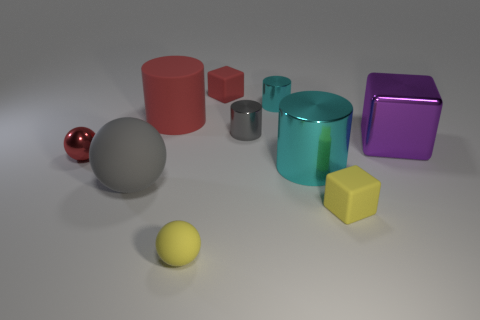What size is the gray matte ball?
Provide a short and direct response. Large. What number of spheres are either gray rubber things or large red objects?
Your answer should be very brief. 1. What size is the red sphere that is made of the same material as the large cyan cylinder?
Your answer should be compact. Small. What number of small shiny things are the same color as the large sphere?
Give a very brief answer. 1. Are there any matte cubes on the left side of the tiny cyan object?
Keep it short and to the point. Yes. There is a gray rubber thing; is its shape the same as the cyan object that is in front of the rubber cylinder?
Provide a succinct answer. No. What number of things are balls in front of the big gray sphere or large purple metal balls?
Give a very brief answer. 1. Are there any other things that are the same material as the big cyan thing?
Ensure brevity in your answer.  Yes. What number of tiny things are both behind the large gray matte ball and in front of the big red rubber object?
Offer a very short reply. 2. How many things are either cylinders that are on the right side of the small matte ball or small objects on the left side of the gray metallic object?
Your answer should be compact. 6. 